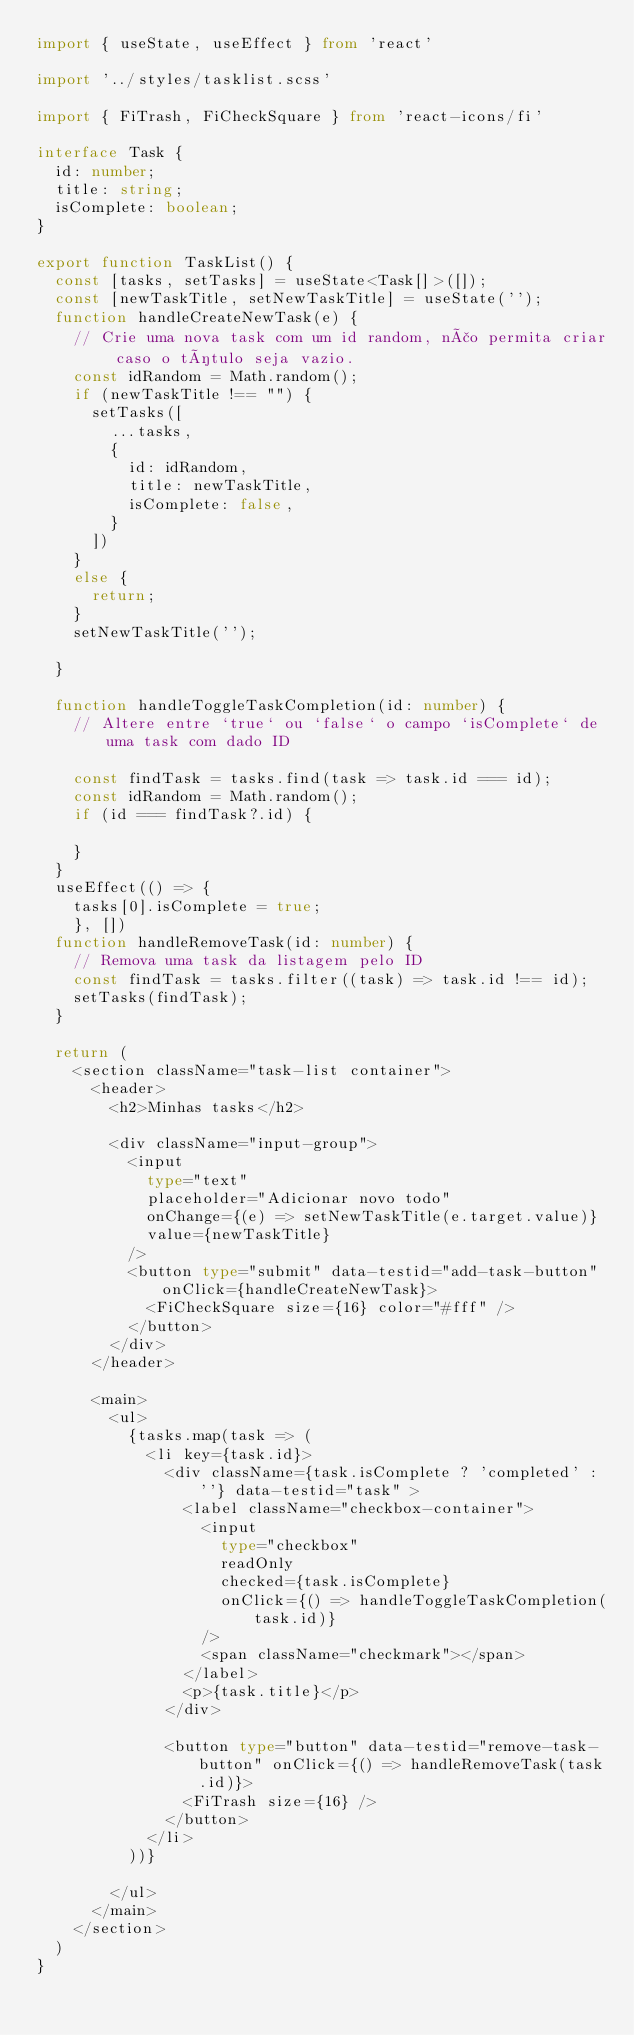<code> <loc_0><loc_0><loc_500><loc_500><_TypeScript_>import { useState, useEffect } from 'react'

import '../styles/tasklist.scss'

import { FiTrash, FiCheckSquare } from 'react-icons/fi'

interface Task {
  id: number;
  title: string;
  isComplete: boolean;
}

export function TaskList() {
  const [tasks, setTasks] = useState<Task[]>([]);
  const [newTaskTitle, setNewTaskTitle] = useState('');
  function handleCreateNewTask(e) {
    // Crie uma nova task com um id random, não permita criar caso o título seja vazio.
    const idRandom = Math.random();
    if (newTaskTitle !== "") {
      setTasks([
        ...tasks,
        {
          id: idRandom,
          title: newTaskTitle,
          isComplete: false,
        }
      ])
    }
    else {
      return;
    }
    setNewTaskTitle('');

  }

  function handleToggleTaskCompletion(id: number) {
    // Altere entre `true` ou `false` o campo `isComplete` de uma task com dado ID

    const findTask = tasks.find(task => task.id === id);
    const idRandom = Math.random();
    if (id === findTask?.id) {
     
    }
  }
  useEffect(() => {
    tasks[0].isComplete = true;
    }, [])
  function handleRemoveTask(id: number) {
    // Remova uma task da listagem pelo ID
    const findTask = tasks.filter((task) => task.id !== id);
    setTasks(findTask);
  }

  return (
    <section className="task-list container">
      <header>
        <h2>Minhas tasks</h2>

        <div className="input-group">
          <input
            type="text"
            placeholder="Adicionar novo todo"
            onChange={(e) => setNewTaskTitle(e.target.value)}
            value={newTaskTitle}
          />
          <button type="submit" data-testid="add-task-button" onClick={handleCreateNewTask}>
            <FiCheckSquare size={16} color="#fff" />
          </button>
        </div>
      </header>

      <main>
        <ul>
          {tasks.map(task => (
            <li key={task.id}>
              <div className={task.isComplete ? 'completed' : ''} data-testid="task" >
                <label className="checkbox-container">
                  <input
                    type="checkbox"
                    readOnly
                    checked={task.isComplete}
                    onClick={() => handleToggleTaskCompletion(task.id)}
                  />
                  <span className="checkmark"></span>
                </label>
                <p>{task.title}</p>
              </div>

              <button type="button" data-testid="remove-task-button" onClick={() => handleRemoveTask(task.id)}>
                <FiTrash size={16} />
              </button>
            </li>
          ))}

        </ul>
      </main>
    </section>
  )
}</code> 